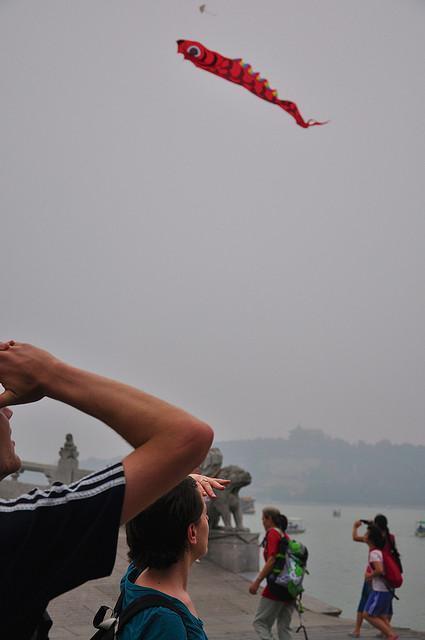How many people can be seen?
Give a very brief answer. 4. 